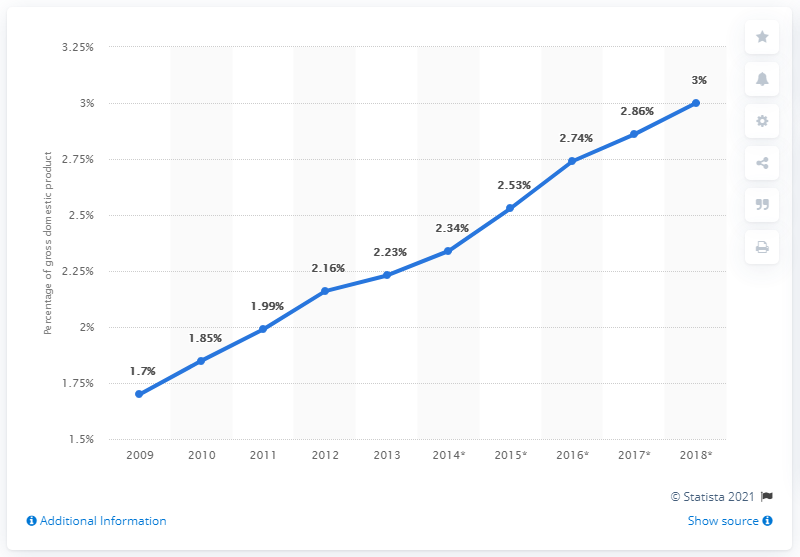Draw attention to some important aspects in this diagram. In 2013, B2C e-commerce accounted for approximately 2.23% of South Korea's Gross Domestic Product (GDP). 